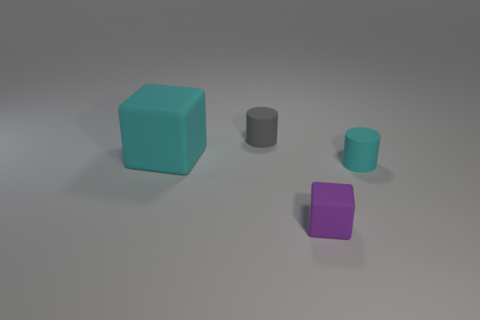Is there any other thing that has the same color as the small rubber cube?
Make the answer very short. No. There is a cyan thing on the left side of the cyan cylinder; is it the same shape as the purple thing?
Ensure brevity in your answer.  Yes. There is a cyan object to the left of the cyan thing right of the rubber block left of the tiny purple rubber block; what size is it?
Your answer should be very brief. Large. How many things are either cyan rubber things or tiny gray cylinders?
Ensure brevity in your answer.  3. There is a rubber object that is right of the large object and behind the tiny cyan cylinder; what shape is it?
Provide a succinct answer. Cylinder. Is the shape of the gray rubber object the same as the cyan rubber object that is to the left of the gray rubber object?
Offer a terse response. No. Are there any cylinders left of the tiny purple matte thing?
Your response must be concise. Yes. What number of cylinders are small blue shiny objects or small gray matte things?
Give a very brief answer. 1. Do the large cyan matte object and the tiny gray object have the same shape?
Your response must be concise. No. What size is the cyan object on the right side of the purple matte block?
Ensure brevity in your answer.  Small. 